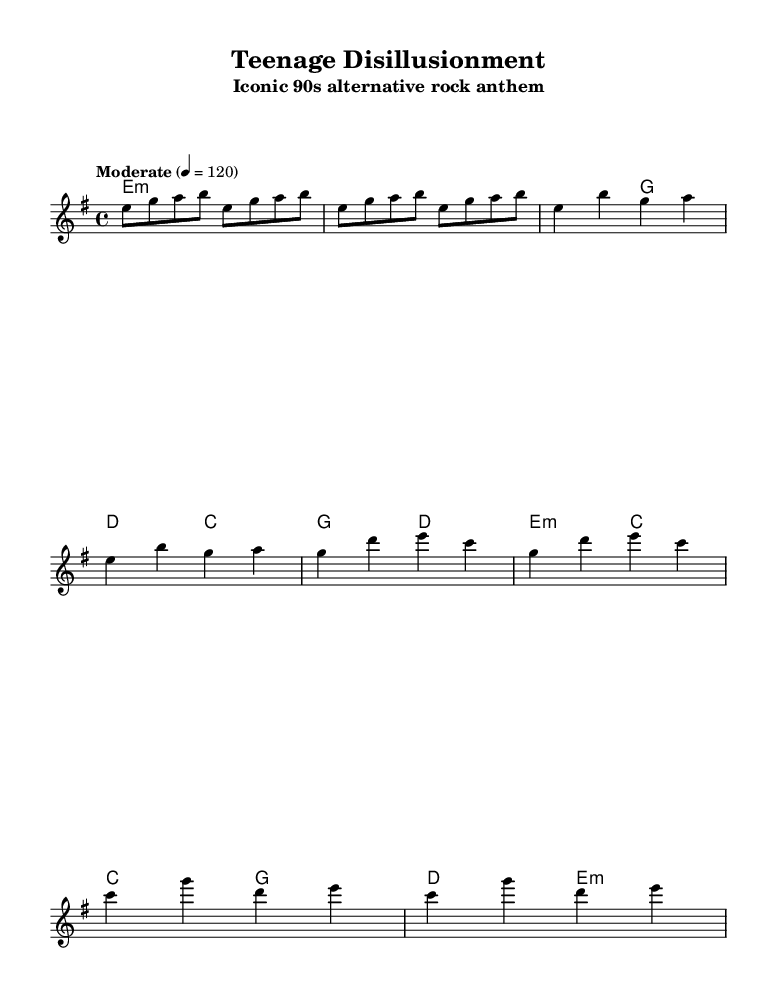What is the key signature of this music? The key signature is E minor, which has one sharp. This is indicated by the `\key e \minor` declaration in the global settings of the sheet music.
Answer: E minor What is the time signature of this piece? The time signature is 4/4, which is standard for popular music and indicated in the global settings of the sheet music as `\time 4/4`.
Answer: 4/4 What is the tempo marking for this music? The tempo marking is "Moderate," set at 120 beats per minute. This is specified in the global settings with `\tempo "Moderate" 4 = 120`.
Answer: Moderate How many measures are there in the chorus section? The chorus section consists of four measures, which can be counted in the melody and harmonies sections labeled as "Chorus."
Answer: 4 Which chord follows the E minor chord in the verse? The chord that follows the E minor chord in the verse is G major. This is found in the chord progression listed under the verse section in the harmonies.
Answer: G major What is the pattern of notes in the bridge section? The bridge section consists of two measures each containing a specific pattern of notes: C, G, D, and E. This pattern can be visually traced from the melody part noted under "Bridge."
Answer: C, G, D, E What is the first note of the melody? The first note of the melody is E. This note is indicated right at the beginning of the melody line in the sheet music.
Answer: E 